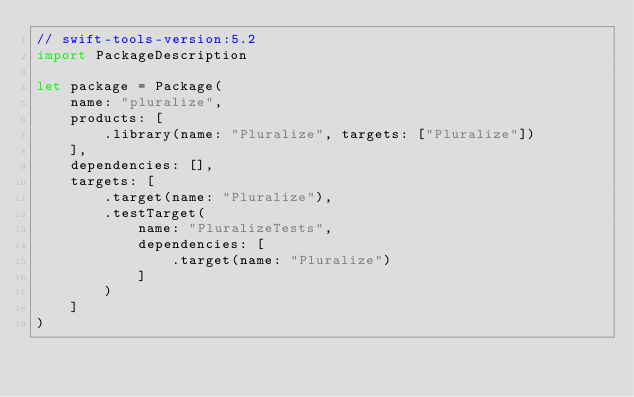Convert code to text. <code><loc_0><loc_0><loc_500><loc_500><_Swift_>// swift-tools-version:5.2
import PackageDescription

let package = Package(
    name: "pluralize",
    products: [
        .library(name: "Pluralize", targets: ["Pluralize"])
    ],
    dependencies: [],
    targets: [
        .target(name: "Pluralize"),
        .testTarget(
            name: "PluralizeTests",
            dependencies: [
                .target(name: "Pluralize")
            ]
        )
    ]
)
</code> 